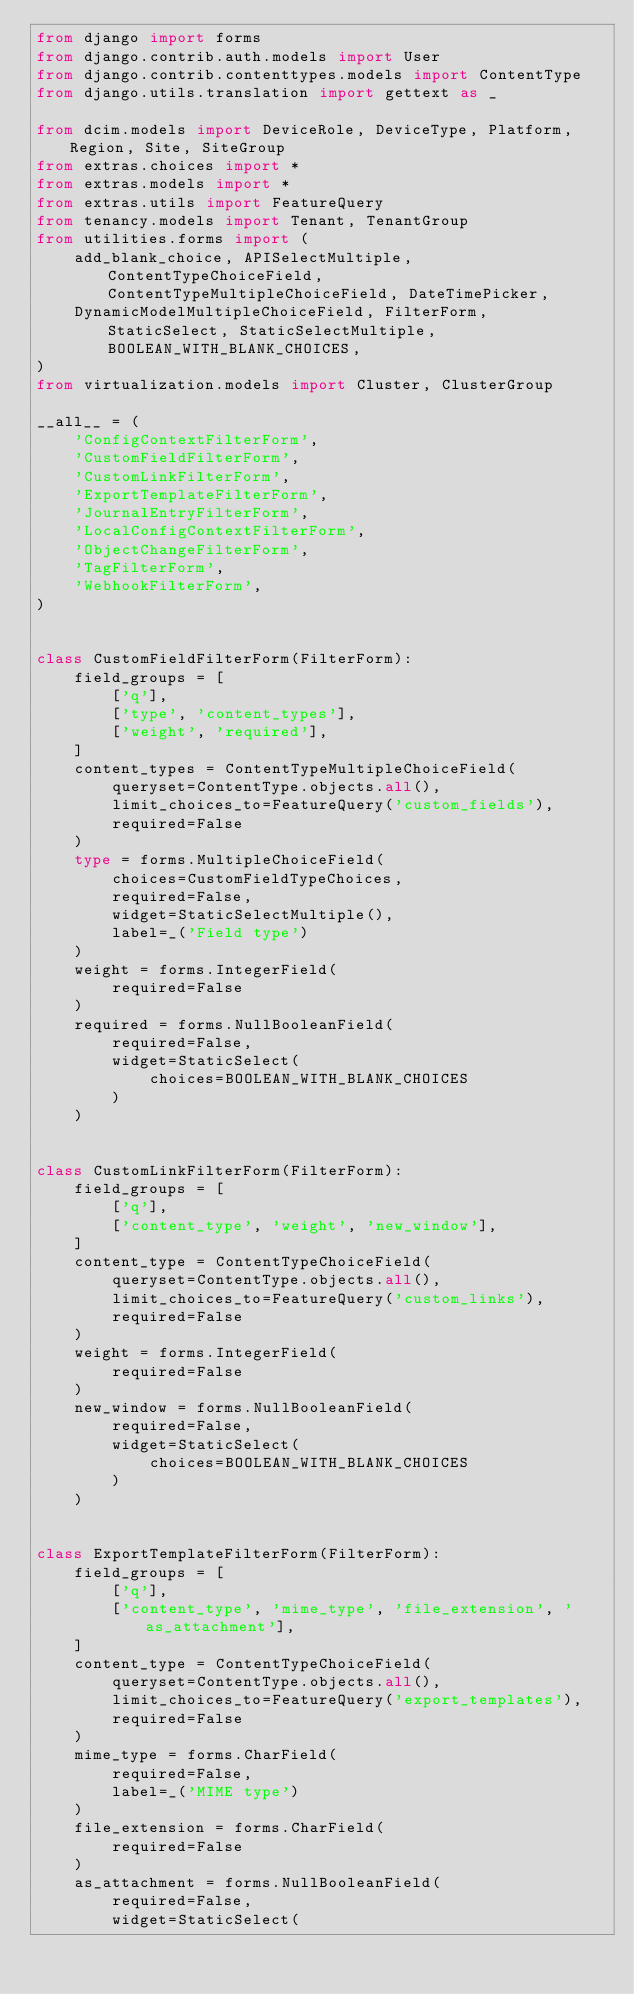Convert code to text. <code><loc_0><loc_0><loc_500><loc_500><_Python_>from django import forms
from django.contrib.auth.models import User
from django.contrib.contenttypes.models import ContentType
from django.utils.translation import gettext as _

from dcim.models import DeviceRole, DeviceType, Platform, Region, Site, SiteGroup
from extras.choices import *
from extras.models import *
from extras.utils import FeatureQuery
from tenancy.models import Tenant, TenantGroup
from utilities.forms import (
    add_blank_choice, APISelectMultiple, ContentTypeChoiceField, ContentTypeMultipleChoiceField, DateTimePicker,
    DynamicModelMultipleChoiceField, FilterForm, StaticSelect, StaticSelectMultiple, BOOLEAN_WITH_BLANK_CHOICES,
)
from virtualization.models import Cluster, ClusterGroup

__all__ = (
    'ConfigContextFilterForm',
    'CustomFieldFilterForm',
    'CustomLinkFilterForm',
    'ExportTemplateFilterForm',
    'JournalEntryFilterForm',
    'LocalConfigContextFilterForm',
    'ObjectChangeFilterForm',
    'TagFilterForm',
    'WebhookFilterForm',
)


class CustomFieldFilterForm(FilterForm):
    field_groups = [
        ['q'],
        ['type', 'content_types'],
        ['weight', 'required'],
    ]
    content_types = ContentTypeMultipleChoiceField(
        queryset=ContentType.objects.all(),
        limit_choices_to=FeatureQuery('custom_fields'),
        required=False
    )
    type = forms.MultipleChoiceField(
        choices=CustomFieldTypeChoices,
        required=False,
        widget=StaticSelectMultiple(),
        label=_('Field type')
    )
    weight = forms.IntegerField(
        required=False
    )
    required = forms.NullBooleanField(
        required=False,
        widget=StaticSelect(
            choices=BOOLEAN_WITH_BLANK_CHOICES
        )
    )


class CustomLinkFilterForm(FilterForm):
    field_groups = [
        ['q'],
        ['content_type', 'weight', 'new_window'],
    ]
    content_type = ContentTypeChoiceField(
        queryset=ContentType.objects.all(),
        limit_choices_to=FeatureQuery('custom_links'),
        required=False
    )
    weight = forms.IntegerField(
        required=False
    )
    new_window = forms.NullBooleanField(
        required=False,
        widget=StaticSelect(
            choices=BOOLEAN_WITH_BLANK_CHOICES
        )
    )


class ExportTemplateFilterForm(FilterForm):
    field_groups = [
        ['q'],
        ['content_type', 'mime_type', 'file_extension', 'as_attachment'],
    ]
    content_type = ContentTypeChoiceField(
        queryset=ContentType.objects.all(),
        limit_choices_to=FeatureQuery('export_templates'),
        required=False
    )
    mime_type = forms.CharField(
        required=False,
        label=_('MIME type')
    )
    file_extension = forms.CharField(
        required=False
    )
    as_attachment = forms.NullBooleanField(
        required=False,
        widget=StaticSelect(</code> 